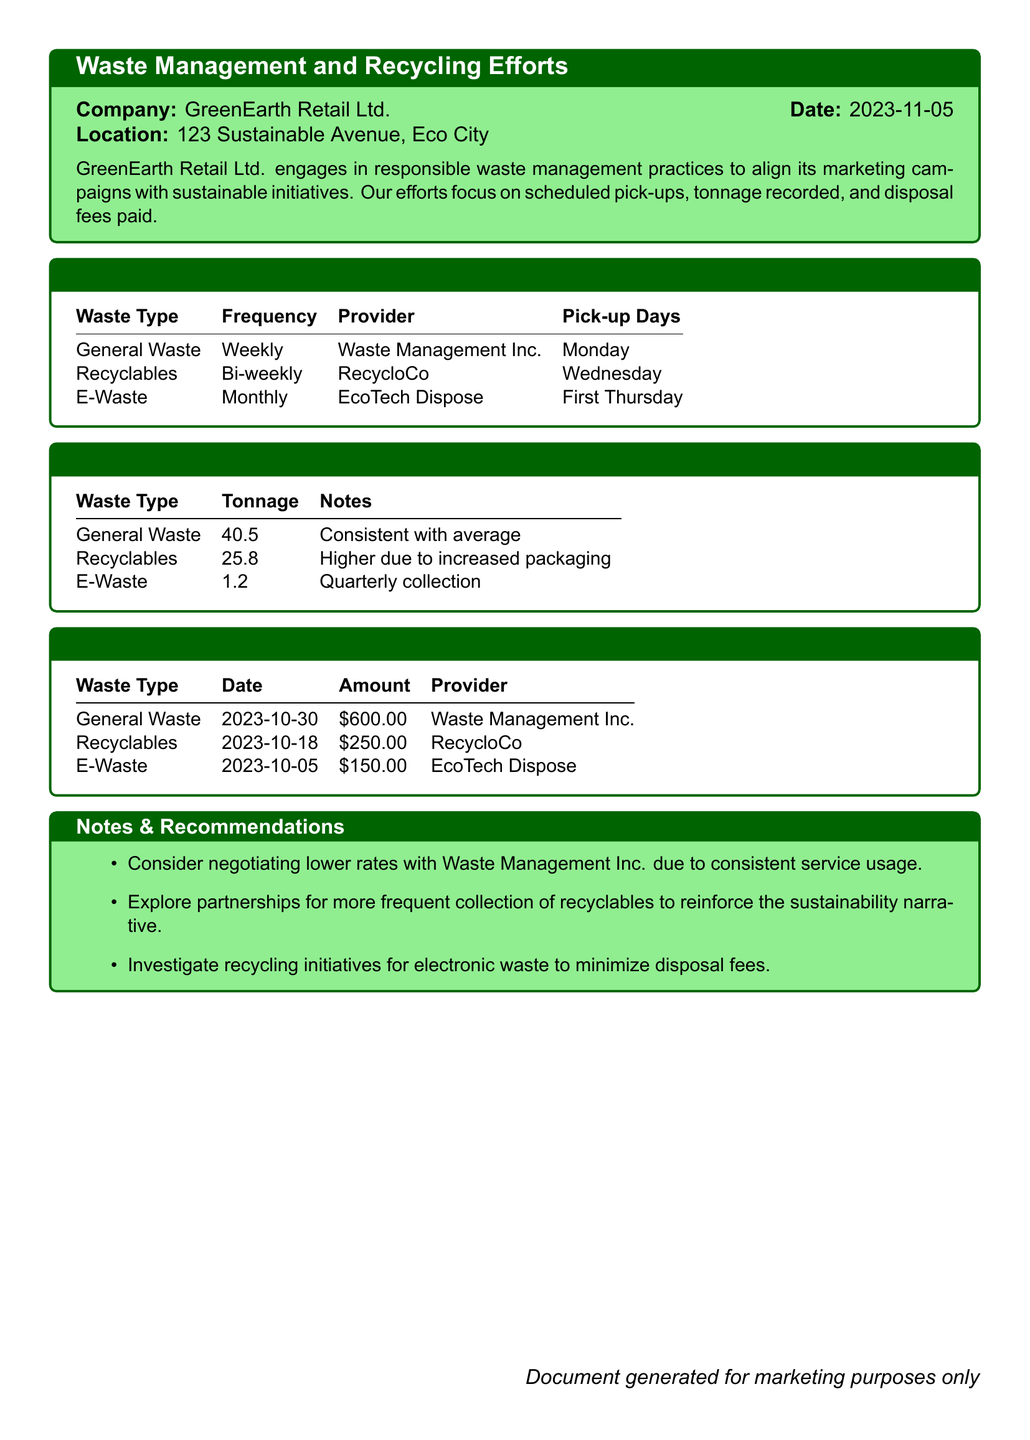What is the frequency of General Waste pick-ups? The frequency of General Waste pick-ups is found in the Scheduled Pick-Ups section.
Answer: Weekly Which provider handles E-Waste disposal? The provider for E-Waste disposal is listed in the Scheduled Pick-Ups section.
Answer: EcoTech Dispose How much was paid for Recyclables disposal? The amount paid for Recyclables disposal is mentioned in the Disposal Fees Paid section.
Answer: $250.00 What was the total tonnage recorded for Recyclables in October 2023? The total tonnage for Recyclables is detailed in the Tonnage Recorded section.
Answer: 25.8 On which date was the General Waste disposal fee paid? The date for the General Waste disposal fee payment can be found in the Disposal Fees Paid section.
Answer: 2023-10-30 What is the average tonnage of General Waste compared to the recorded amount? The notes in the Tonnage Recorded section state it is consistent with the average.
Answer: Consistent with average How much has been spent on E-Waste disposal in total? The total spent on E-Waste disposal is listed in the Disposal Fees Paid section.
Answer: $150.00 What recommendation is made regarding Waste Management Inc.? The recommendation about Waste Management Inc. is noted in the Notes & Recommendations section.
Answer: Negotiate lower rates Which waste type had a higher tonnage due to increased packaging? The tonnage affected by increased packaging is provided in the Tonnage Recorded section.
Answer: Recyclables 